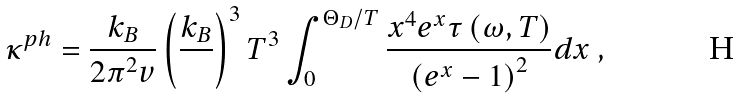Convert formula to latex. <formula><loc_0><loc_0><loc_500><loc_500>\kappa ^ { p h } = \frac { k _ { B } } { 2 { \pi } ^ { 2 } v } \left ( \frac { k _ { B } } { } \right ) ^ { 3 } T ^ { 3 } \int _ { 0 } ^ { \Theta _ { D } / T } \frac { x ^ { 4 } e ^ { x } \tau \left ( \omega , T \right ) } { \left ( e ^ { x } - 1 \right ) ^ { 2 } } d x \ ,</formula> 